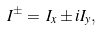<formula> <loc_0><loc_0><loc_500><loc_500>I ^ { \pm } = \, I _ { x } \pm i I _ { y } ,</formula> 